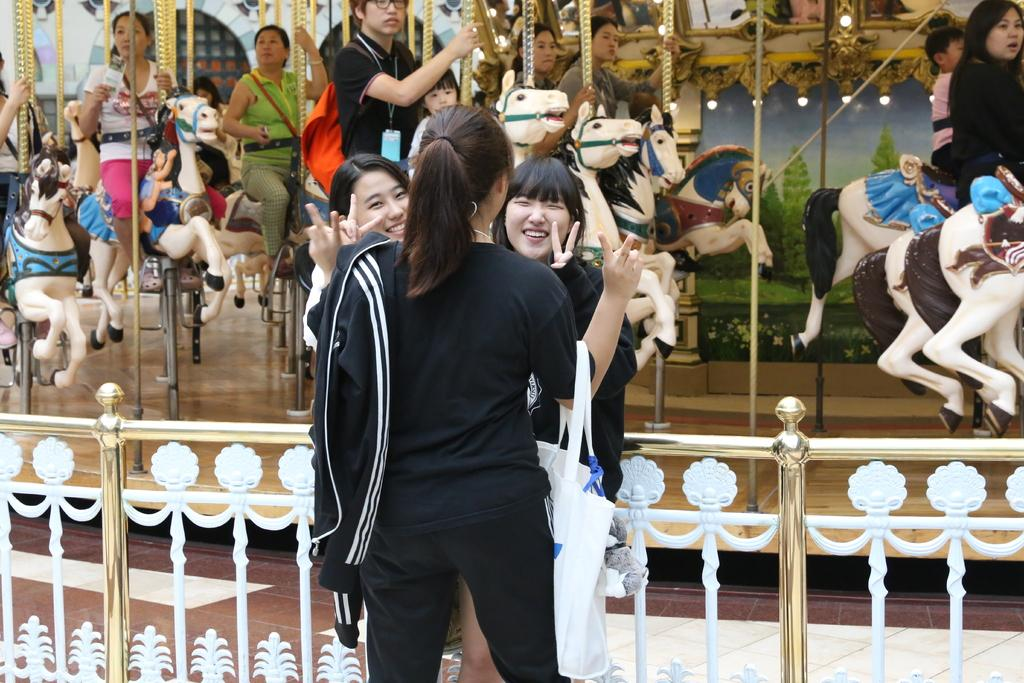How many people are present in the image? There are three persons standing in the image. What is visible behind the three persons? There is railing visible behind the three persons. What can be seen in the background of the image? There are people sitting on a carousel in the background of the image. What type of pen is being used by the person on the left in the image? There is no pen visible in the image, as the focus is on the three persons standing and the carousel in the background. 